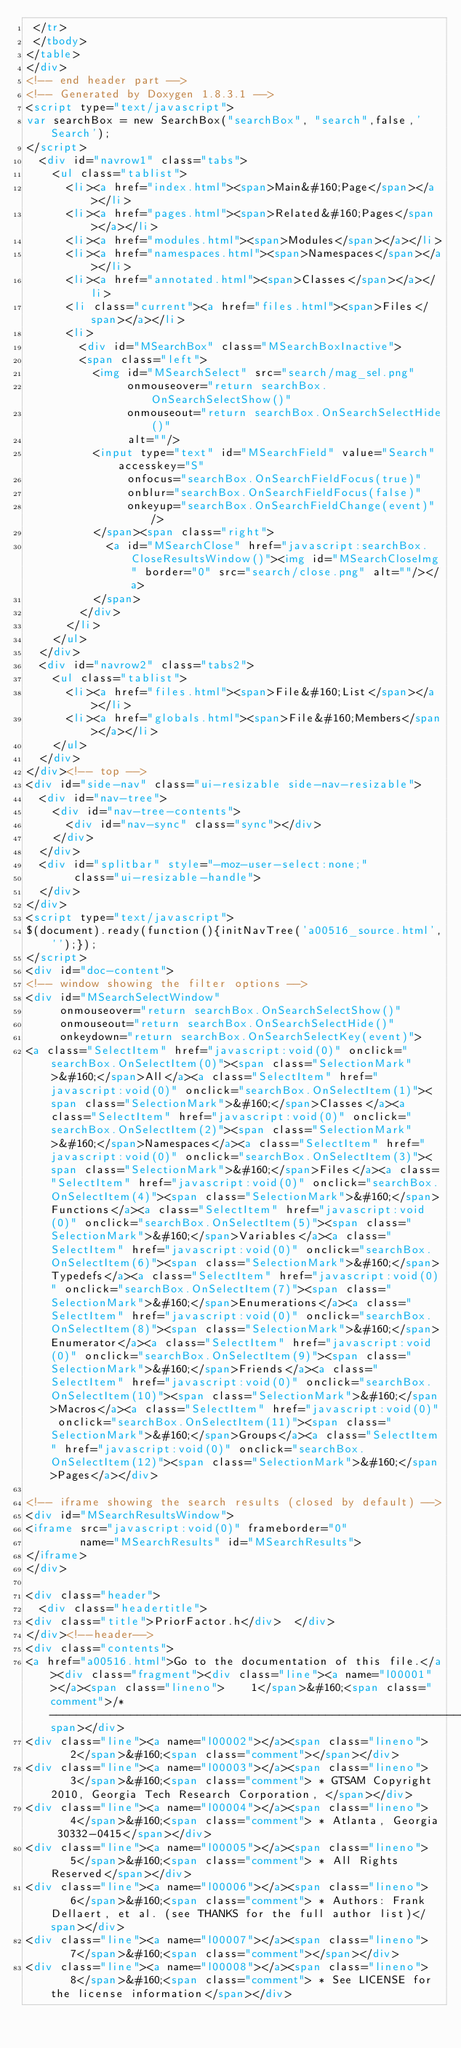<code> <loc_0><loc_0><loc_500><loc_500><_HTML_> </tr>
 </tbody>
</table>
</div>
<!-- end header part -->
<!-- Generated by Doxygen 1.8.3.1 -->
<script type="text/javascript">
var searchBox = new SearchBox("searchBox", "search",false,'Search');
</script>
  <div id="navrow1" class="tabs">
    <ul class="tablist">
      <li><a href="index.html"><span>Main&#160;Page</span></a></li>
      <li><a href="pages.html"><span>Related&#160;Pages</span></a></li>
      <li><a href="modules.html"><span>Modules</span></a></li>
      <li><a href="namespaces.html"><span>Namespaces</span></a></li>
      <li><a href="annotated.html"><span>Classes</span></a></li>
      <li class="current"><a href="files.html"><span>Files</span></a></li>
      <li>
        <div id="MSearchBox" class="MSearchBoxInactive">
        <span class="left">
          <img id="MSearchSelect" src="search/mag_sel.png"
               onmouseover="return searchBox.OnSearchSelectShow()"
               onmouseout="return searchBox.OnSearchSelectHide()"
               alt=""/>
          <input type="text" id="MSearchField" value="Search" accesskey="S"
               onfocus="searchBox.OnSearchFieldFocus(true)" 
               onblur="searchBox.OnSearchFieldFocus(false)" 
               onkeyup="searchBox.OnSearchFieldChange(event)"/>
          </span><span class="right">
            <a id="MSearchClose" href="javascript:searchBox.CloseResultsWindow()"><img id="MSearchCloseImg" border="0" src="search/close.png" alt=""/></a>
          </span>
        </div>
      </li>
    </ul>
  </div>
  <div id="navrow2" class="tabs2">
    <ul class="tablist">
      <li><a href="files.html"><span>File&#160;List</span></a></li>
      <li><a href="globals.html"><span>File&#160;Members</span></a></li>
    </ul>
  </div>
</div><!-- top -->
<div id="side-nav" class="ui-resizable side-nav-resizable">
  <div id="nav-tree">
    <div id="nav-tree-contents">
      <div id="nav-sync" class="sync"></div>
    </div>
  </div>
  <div id="splitbar" style="-moz-user-select:none;" 
       class="ui-resizable-handle">
  </div>
</div>
<script type="text/javascript">
$(document).ready(function(){initNavTree('a00516_source.html','');});
</script>
<div id="doc-content">
<!-- window showing the filter options -->
<div id="MSearchSelectWindow"
     onmouseover="return searchBox.OnSearchSelectShow()"
     onmouseout="return searchBox.OnSearchSelectHide()"
     onkeydown="return searchBox.OnSearchSelectKey(event)">
<a class="SelectItem" href="javascript:void(0)" onclick="searchBox.OnSelectItem(0)"><span class="SelectionMark">&#160;</span>All</a><a class="SelectItem" href="javascript:void(0)" onclick="searchBox.OnSelectItem(1)"><span class="SelectionMark">&#160;</span>Classes</a><a class="SelectItem" href="javascript:void(0)" onclick="searchBox.OnSelectItem(2)"><span class="SelectionMark">&#160;</span>Namespaces</a><a class="SelectItem" href="javascript:void(0)" onclick="searchBox.OnSelectItem(3)"><span class="SelectionMark">&#160;</span>Files</a><a class="SelectItem" href="javascript:void(0)" onclick="searchBox.OnSelectItem(4)"><span class="SelectionMark">&#160;</span>Functions</a><a class="SelectItem" href="javascript:void(0)" onclick="searchBox.OnSelectItem(5)"><span class="SelectionMark">&#160;</span>Variables</a><a class="SelectItem" href="javascript:void(0)" onclick="searchBox.OnSelectItem(6)"><span class="SelectionMark">&#160;</span>Typedefs</a><a class="SelectItem" href="javascript:void(0)" onclick="searchBox.OnSelectItem(7)"><span class="SelectionMark">&#160;</span>Enumerations</a><a class="SelectItem" href="javascript:void(0)" onclick="searchBox.OnSelectItem(8)"><span class="SelectionMark">&#160;</span>Enumerator</a><a class="SelectItem" href="javascript:void(0)" onclick="searchBox.OnSelectItem(9)"><span class="SelectionMark">&#160;</span>Friends</a><a class="SelectItem" href="javascript:void(0)" onclick="searchBox.OnSelectItem(10)"><span class="SelectionMark">&#160;</span>Macros</a><a class="SelectItem" href="javascript:void(0)" onclick="searchBox.OnSelectItem(11)"><span class="SelectionMark">&#160;</span>Groups</a><a class="SelectItem" href="javascript:void(0)" onclick="searchBox.OnSelectItem(12)"><span class="SelectionMark">&#160;</span>Pages</a></div>

<!-- iframe showing the search results (closed by default) -->
<div id="MSearchResultsWindow">
<iframe src="javascript:void(0)" frameborder="0" 
        name="MSearchResults" id="MSearchResults">
</iframe>
</div>

<div class="header">
  <div class="headertitle">
<div class="title">PriorFactor.h</div>  </div>
</div><!--header-->
<div class="contents">
<a href="a00516.html">Go to the documentation of this file.</a><div class="fragment"><div class="line"><a name="l00001"></a><span class="lineno">    1</span>&#160;<span class="comment">/* ----------------------------------------------------------------------------</span></div>
<div class="line"><a name="l00002"></a><span class="lineno">    2</span>&#160;<span class="comment"></span></div>
<div class="line"><a name="l00003"></a><span class="lineno">    3</span>&#160;<span class="comment"> * GTSAM Copyright 2010, Georgia Tech Research Corporation, </span></div>
<div class="line"><a name="l00004"></a><span class="lineno">    4</span>&#160;<span class="comment"> * Atlanta, Georgia 30332-0415</span></div>
<div class="line"><a name="l00005"></a><span class="lineno">    5</span>&#160;<span class="comment"> * All Rights Reserved</span></div>
<div class="line"><a name="l00006"></a><span class="lineno">    6</span>&#160;<span class="comment"> * Authors: Frank Dellaert, et al. (see THANKS for the full author list)</span></div>
<div class="line"><a name="l00007"></a><span class="lineno">    7</span>&#160;<span class="comment"></span></div>
<div class="line"><a name="l00008"></a><span class="lineno">    8</span>&#160;<span class="comment"> * See LICENSE for the license information</span></div></code> 